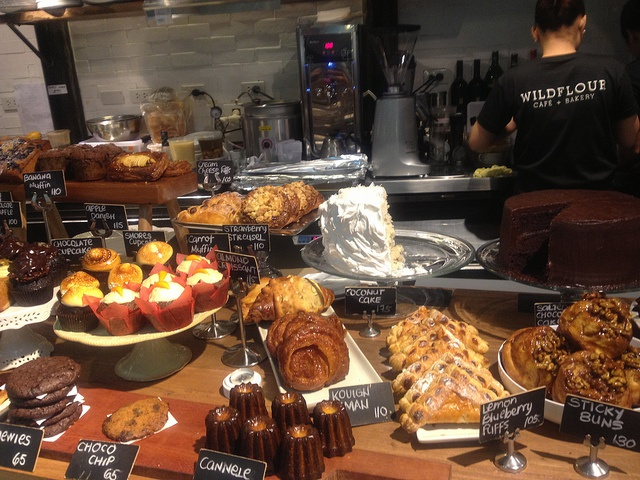Describe the objects in this image and their specific colors. I can see people in gray, black, maroon, and tan tones, cake in gray, black, maroon, and brown tones, cake in gray, ivory, darkgray, and tan tones, bottle in gray, black, and maroon tones, and donut in gray, maroon, brown, and black tones in this image. 